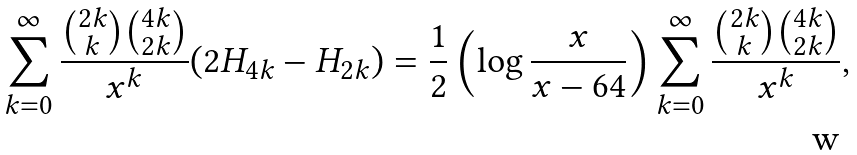<formula> <loc_0><loc_0><loc_500><loc_500>& \sum _ { k = 0 } ^ { \infty } \frac { \binom { 2 k } { k } \binom { 4 k } { 2 k } } { x ^ { k } } ( 2 H _ { 4 k } - H _ { 2 k } ) = \frac { 1 } { 2 } \left ( \log \frac { x } { x - 6 4 } \right ) \sum _ { k = 0 } ^ { \infty } \frac { \binom { 2 k } { k } \binom { 4 k } { 2 k } } { x ^ { k } } ,</formula> 